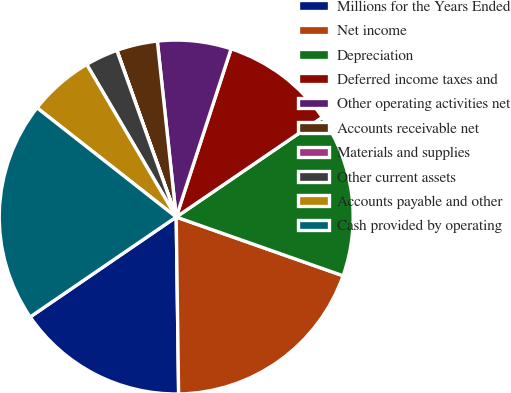Convert chart. <chart><loc_0><loc_0><loc_500><loc_500><pie_chart><fcel>Millions for the Years Ended<fcel>Net income<fcel>Depreciation<fcel>Deferred income taxes and<fcel>Other operating activities net<fcel>Accounts receivable net<fcel>Materials and supplies<fcel>Other current assets<fcel>Accounts payable and other<fcel>Cash provided by operating<nl><fcel>15.67%<fcel>19.4%<fcel>14.92%<fcel>10.45%<fcel>6.72%<fcel>3.74%<fcel>0.01%<fcel>2.99%<fcel>5.97%<fcel>20.14%<nl></chart> 